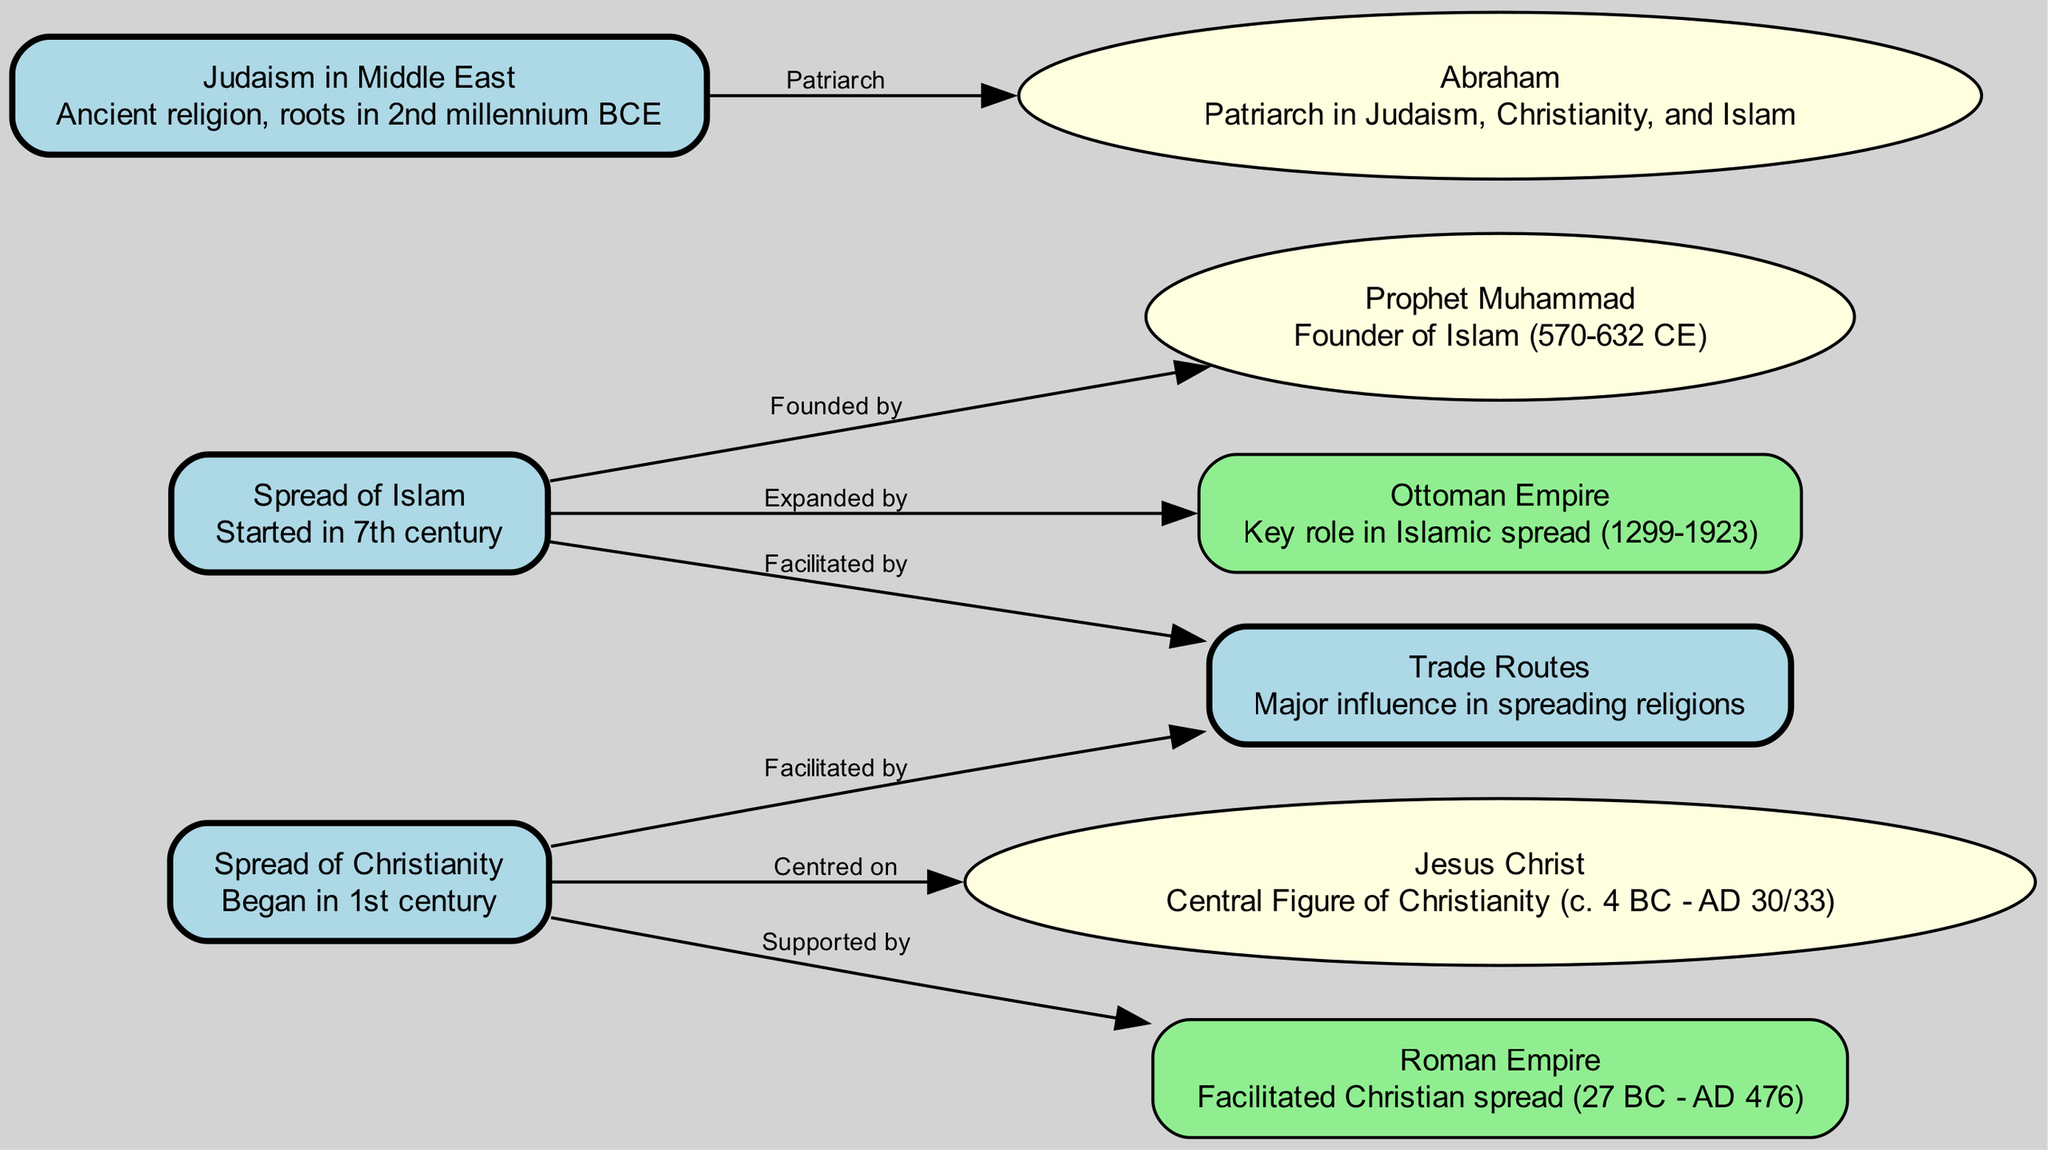What is the starting century of the spread of Islam? The diagram indicates the "Spread of Islam" node has a detail stating it started in the 7th century, which is directly shown in the accompanying text.
Answer: 7th century Who is the central figure of Christianity? From the diagram, the "Spread of Christianity" node links to "Jesus Christ," which is labeled as the central figure of Christianity, reinforcing this relationship.
Answer: Jesus Christ How many major religions are represented in the diagram? The nodes detail three major religions: Islam, Christianity, and Judaism. By counting the nodes under the religious spread, we identify three representations.
Answer: 3 What role did the Ottoman Empire have in Islam's spread? The diagram shows an edge from "Spread of Islam" to "Ottoman Empire," labeled "Expanded by," clearly indicating the Ottoman Empire's role in the dissemination of Islam.
Answer: Expanded by What facilitated both the spread of Islam and Christianity? The "spread_routes" node is linked to both "Spread of Islam" and "Spread of Christianity," with the edge labels indicating that trade routes facilitated both religions' spread.
Answer: Trade Routes Which ancient religion has roots in the 2nd millennium BCE? The node labeled "Judaism in Middle East" indicates that it is an ancient religion with roots in the 2nd millennium BCE, as stated in its details.
Answer: Judaism What significant empire facilitated the spread of Christianity? The relationship between "Spread of Christianity" and "Roman Empire" is described in the diagram with the edge label "Supported by," indicating the Roman Empire's significance in facilitating Christianity.
Answer: Roman Empire Identify the patriarch shared by Judaism, Christianity, and Islam. The diagram indicates that "Abraham" is linked to all three religions, as shown from the node detailing "Judaism in Middle East." Thus, Abraham serves as the common patriarch.
Answer: Abraham 